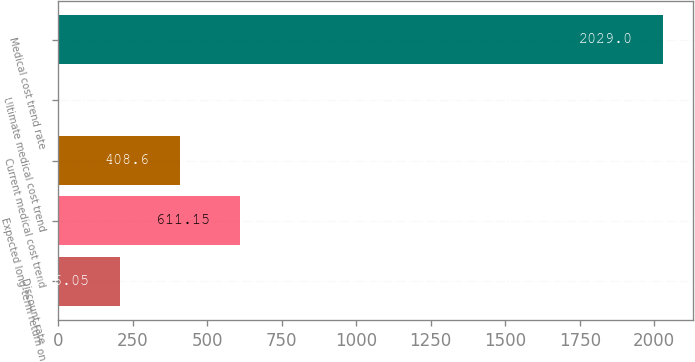Convert chart. <chart><loc_0><loc_0><loc_500><loc_500><bar_chart><fcel>Discount rate<fcel>Expected long-term return on<fcel>Current medical cost trend<fcel>Ultimate medical cost trend<fcel>Medical cost trend rate<nl><fcel>206.05<fcel>611.15<fcel>408.6<fcel>3.5<fcel>2029<nl></chart> 